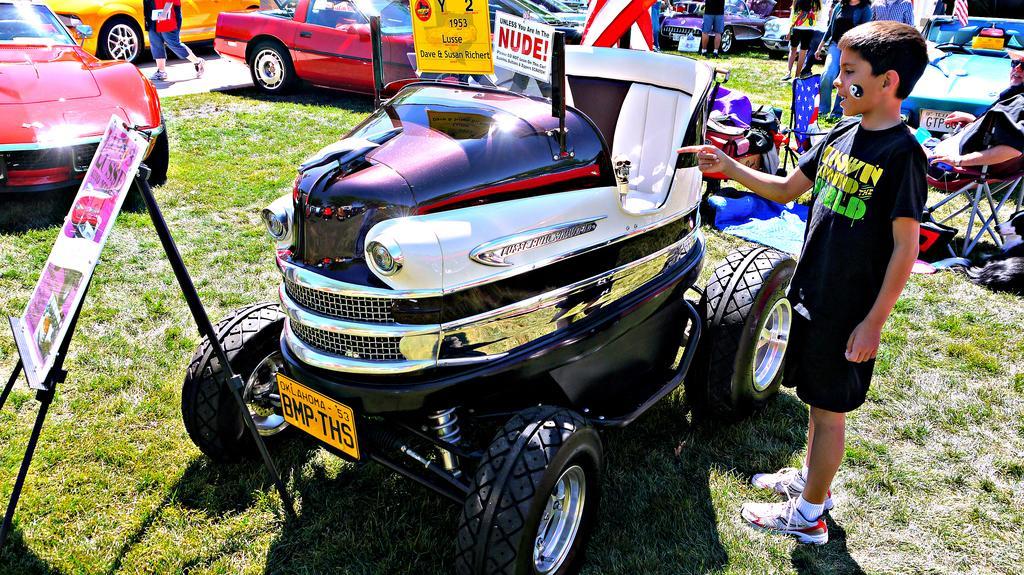Can you describe this image briefly? In this picture we can see vehicles, people, objects and boards. On the right side of the picture we can see a man wearing goggles and sitting on a chair. We can see a boy standing and pointing his finger towards a vehicle. At the bottom portion of the picture we can see grass. 